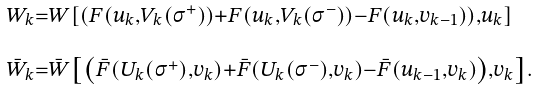<formula> <loc_0><loc_0><loc_500><loc_500>\begin{array} { l } ^ { W _ { k } = W \left [ \left ( F ( u _ { k } , V _ { k } ( \sigma ^ { + } ) ) + F ( u _ { k } , V _ { k } ( \sigma ^ { - } ) ) - F ( u _ { k } , v _ { k - 1 } ) \right ) , u _ { k } \right ] } \\ _ { \bar { W } _ { k } = \bar { W } \left [ \left ( \bar { F } ( U _ { k } ( \sigma ^ { + } ) , v _ { k } ) + \bar { F } ( U _ { k } ( \sigma ^ { - } ) , v _ { k } ) - \bar { F } ( u _ { k - 1 } , v _ { k } ) \right ) , v _ { k } \right ] . } \end{array}</formula> 